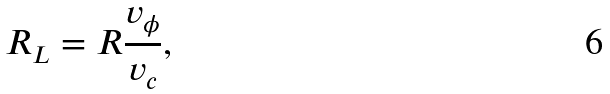<formula> <loc_0><loc_0><loc_500><loc_500>R _ { L } = R \frac { v _ { \phi } } { v _ { c } } ,</formula> 